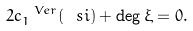<formula> <loc_0><loc_0><loc_500><loc_500>\label l { e q \colon d e g x i } 2 c _ { 1 } ^ { \ V e r } ( \ s i ) + \deg \xi = 0 .</formula> 